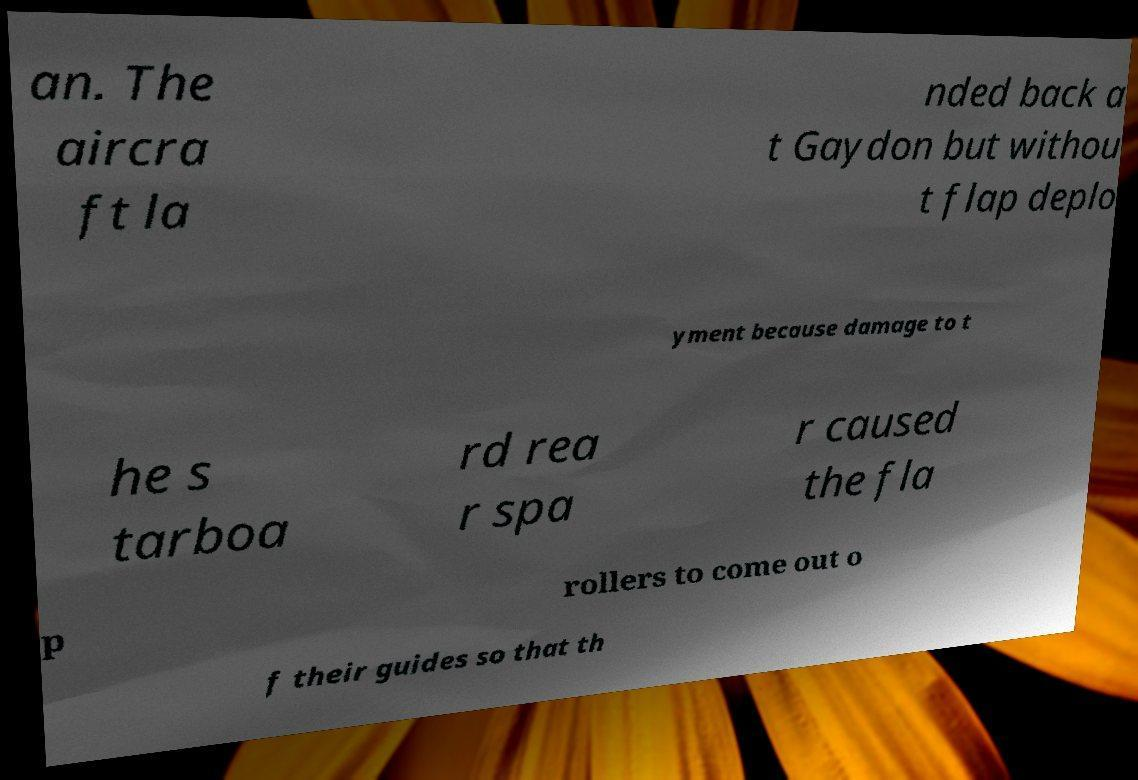Can you accurately transcribe the text from the provided image for me? an. The aircra ft la nded back a t Gaydon but withou t flap deplo yment because damage to t he s tarboa rd rea r spa r caused the fla p rollers to come out o f their guides so that th 